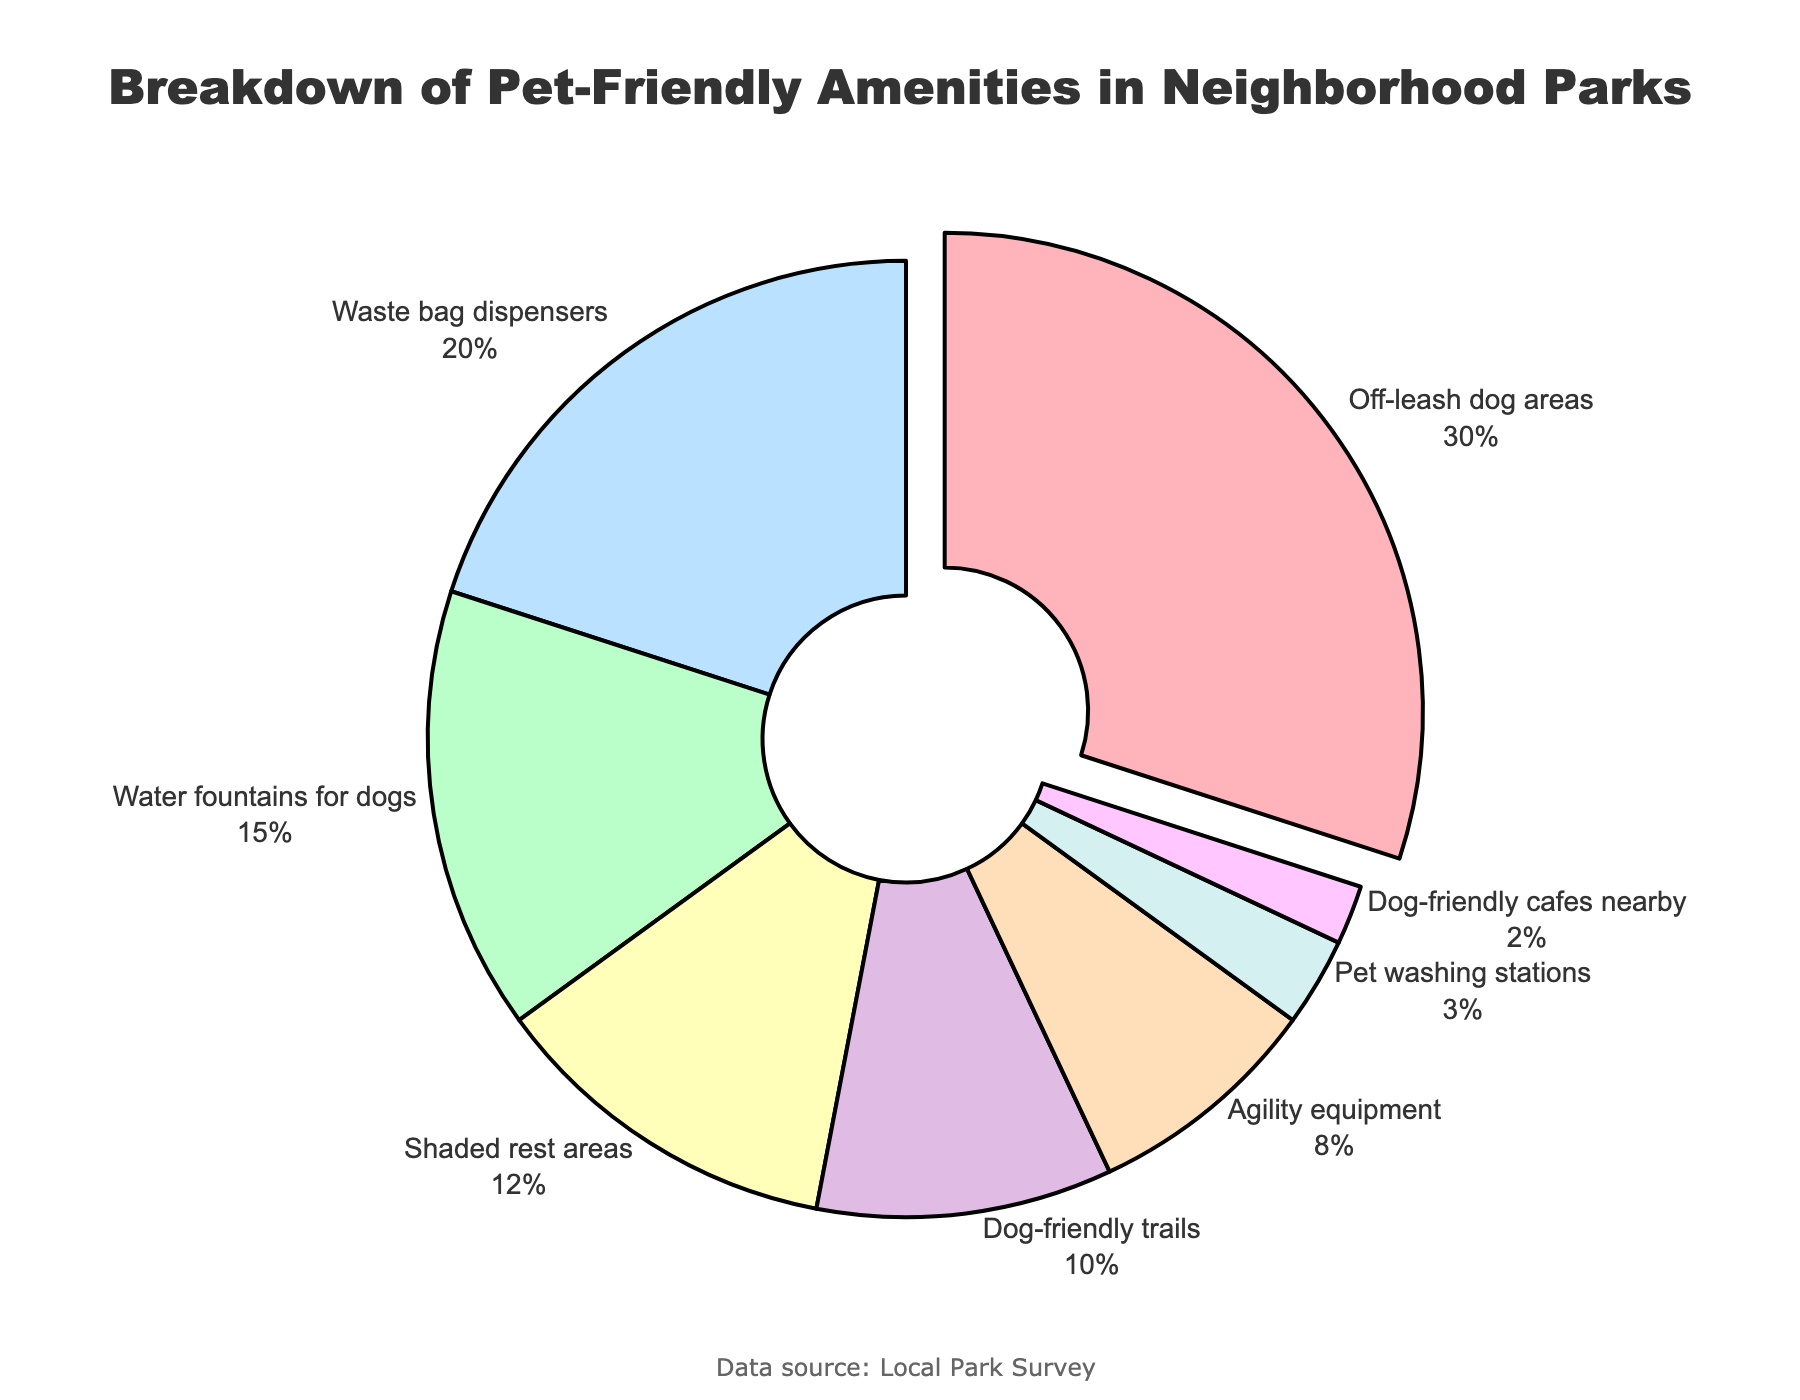What's the most common pet-friendly amenity in neighborhood parks? The pie chart shows the percentage breakdown of each amenity. The largest section of the pie chart corresponds to "Off-leash dog areas," which accounts for 30% of the amenities.
Answer: Off-leash dog areas Which amenity is the least common? By looking at the smallest section of the pie chart, we can identify the least common amenity. The segment labeled "Dog-friendly cafes nearby" contributes only 2% of the total.
Answer: Dog-friendly cafes nearby How much more common are waste bag dispensers compared to agility equipment? The chart shows waste bag dispensers at 20% and agility equipment at 8%. Subtract the percentage of agility equipment from that of waste bag dispensers to find the difference: 20% - 8% = 12%.
Answer: 12% What percentage of amenities are dedicated to dog hydration (including water fountains for dogs and pet washing stations)? To find the total percentage dedicated to dog hydration, add the percentages of water fountains for dogs (15%) and pet washing stations (3%): 15% + 3% = 18%.
Answer: 18% Are shaded rest areas more common than dog-friendly trails? The chart shows shaded rest areas at 12% and dog-friendly trails at 10%. Since 12% is greater than 10%, shaded rest areas are indeed more common.
Answer: Yes What two amenities together make up exactly half of the total amenities? By looking at the pie chart, find two segments that together total 50%. "Off-leash dog areas" (30%) and "Waste bag dispensers" (20%) add up to 30% + 20% = 50%.
Answer: Off-leash dog areas and waste bag dispensers What is the combined percentage of shaded rest areas, agility equipment, and dog-friendly trails? Add the percentages of shaded rest areas (12%), agility equipment (8%), and dog-friendly trails (10%): 12% + 8% + 10% = 30%.
Answer: 30% Which sections of the pie chart are represented by shades of blue? Visually identify sections colored in shades of blue. The chart has light blue for "Shaded rest areas" (12%) and dark blue for "Dog-friendly trails" (10%).
Answer: Shaded rest areas and dog-friendly trails Is the share of water fountains for dogs greater than the combined share of pet washing stations and dog-friendly cafes nearby? The percentage for water fountains for dogs is 15%. The combined percentage for pet washing stations (3%) and dog-friendly cafes nearby (2%) is 3% + 2% = 5%. Since 15% is greater than 5%, water fountains for dogs are indeed more common.
Answer: Yes What fraction of the pie chart does agility equipment represent? The percentage for agility equipment is 8%. To convert this to a fraction, we note that 8% is equivalent to 8/100 or simplified to 2/25.
Answer: 2/25 